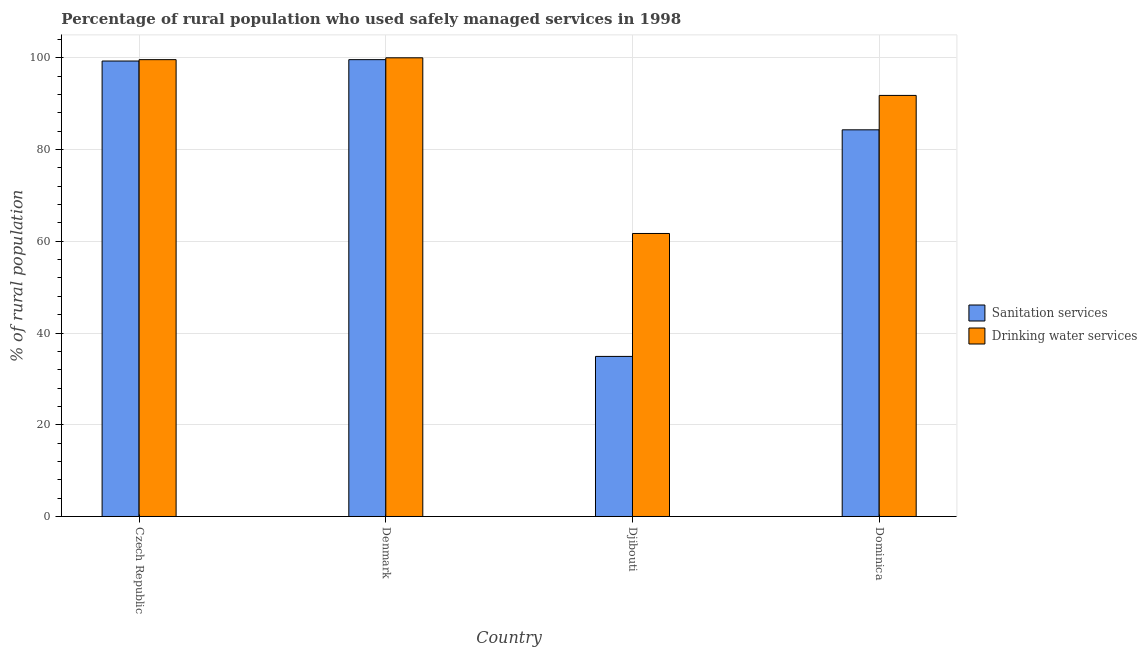How many different coloured bars are there?
Your response must be concise. 2. How many groups of bars are there?
Make the answer very short. 4. Are the number of bars per tick equal to the number of legend labels?
Your answer should be very brief. Yes. Are the number of bars on each tick of the X-axis equal?
Make the answer very short. Yes. How many bars are there on the 2nd tick from the left?
Offer a very short reply. 2. What is the percentage of rural population who used drinking water services in Czech Republic?
Offer a terse response. 99.6. Across all countries, what is the maximum percentage of rural population who used sanitation services?
Provide a succinct answer. 99.6. Across all countries, what is the minimum percentage of rural population who used drinking water services?
Offer a very short reply. 61.7. In which country was the percentage of rural population who used sanitation services maximum?
Ensure brevity in your answer.  Denmark. In which country was the percentage of rural population who used drinking water services minimum?
Offer a very short reply. Djibouti. What is the total percentage of rural population who used drinking water services in the graph?
Provide a succinct answer. 353.1. What is the difference between the percentage of rural population who used sanitation services in Czech Republic and that in Djibouti?
Keep it short and to the point. 64.4. What is the difference between the percentage of rural population who used sanitation services in Djibouti and the percentage of rural population who used drinking water services in Czech Republic?
Ensure brevity in your answer.  -64.7. What is the average percentage of rural population who used sanitation services per country?
Keep it short and to the point. 79.52. What is the difference between the percentage of rural population who used drinking water services and percentage of rural population who used sanitation services in Djibouti?
Keep it short and to the point. 26.8. What is the ratio of the percentage of rural population who used drinking water services in Denmark to that in Djibouti?
Give a very brief answer. 1.62. Is the percentage of rural population who used drinking water services in Djibouti less than that in Dominica?
Offer a terse response. Yes. What is the difference between the highest and the second highest percentage of rural population who used sanitation services?
Ensure brevity in your answer.  0.3. What is the difference between the highest and the lowest percentage of rural population who used sanitation services?
Offer a terse response. 64.7. In how many countries, is the percentage of rural population who used drinking water services greater than the average percentage of rural population who used drinking water services taken over all countries?
Ensure brevity in your answer.  3. What does the 2nd bar from the left in Djibouti represents?
Give a very brief answer. Drinking water services. What does the 1st bar from the right in Denmark represents?
Keep it short and to the point. Drinking water services. How many bars are there?
Ensure brevity in your answer.  8. Are all the bars in the graph horizontal?
Provide a succinct answer. No. What is the difference between two consecutive major ticks on the Y-axis?
Offer a terse response. 20. How are the legend labels stacked?
Provide a short and direct response. Vertical. What is the title of the graph?
Offer a very short reply. Percentage of rural population who used safely managed services in 1998. Does "Forest land" appear as one of the legend labels in the graph?
Provide a succinct answer. No. What is the label or title of the Y-axis?
Provide a short and direct response. % of rural population. What is the % of rural population in Sanitation services in Czech Republic?
Offer a terse response. 99.3. What is the % of rural population of Drinking water services in Czech Republic?
Keep it short and to the point. 99.6. What is the % of rural population in Sanitation services in Denmark?
Offer a terse response. 99.6. What is the % of rural population in Sanitation services in Djibouti?
Offer a terse response. 34.9. What is the % of rural population of Drinking water services in Djibouti?
Make the answer very short. 61.7. What is the % of rural population of Sanitation services in Dominica?
Your answer should be compact. 84.3. What is the % of rural population in Drinking water services in Dominica?
Give a very brief answer. 91.8. Across all countries, what is the maximum % of rural population of Sanitation services?
Your response must be concise. 99.6. Across all countries, what is the minimum % of rural population in Sanitation services?
Offer a terse response. 34.9. Across all countries, what is the minimum % of rural population in Drinking water services?
Give a very brief answer. 61.7. What is the total % of rural population of Sanitation services in the graph?
Keep it short and to the point. 318.1. What is the total % of rural population in Drinking water services in the graph?
Offer a terse response. 353.1. What is the difference between the % of rural population in Sanitation services in Czech Republic and that in Denmark?
Ensure brevity in your answer.  -0.3. What is the difference between the % of rural population in Sanitation services in Czech Republic and that in Djibouti?
Ensure brevity in your answer.  64.4. What is the difference between the % of rural population in Drinking water services in Czech Republic and that in Djibouti?
Ensure brevity in your answer.  37.9. What is the difference between the % of rural population in Drinking water services in Czech Republic and that in Dominica?
Your response must be concise. 7.8. What is the difference between the % of rural population in Sanitation services in Denmark and that in Djibouti?
Offer a very short reply. 64.7. What is the difference between the % of rural population of Drinking water services in Denmark and that in Djibouti?
Offer a terse response. 38.3. What is the difference between the % of rural population of Drinking water services in Denmark and that in Dominica?
Make the answer very short. 8.2. What is the difference between the % of rural population in Sanitation services in Djibouti and that in Dominica?
Your response must be concise. -49.4. What is the difference between the % of rural population in Drinking water services in Djibouti and that in Dominica?
Give a very brief answer. -30.1. What is the difference between the % of rural population in Sanitation services in Czech Republic and the % of rural population in Drinking water services in Djibouti?
Offer a very short reply. 37.6. What is the difference between the % of rural population in Sanitation services in Denmark and the % of rural population in Drinking water services in Djibouti?
Your answer should be compact. 37.9. What is the difference between the % of rural population in Sanitation services in Denmark and the % of rural population in Drinking water services in Dominica?
Offer a terse response. 7.8. What is the difference between the % of rural population in Sanitation services in Djibouti and the % of rural population in Drinking water services in Dominica?
Offer a terse response. -56.9. What is the average % of rural population in Sanitation services per country?
Provide a short and direct response. 79.53. What is the average % of rural population in Drinking water services per country?
Your answer should be very brief. 88.28. What is the difference between the % of rural population of Sanitation services and % of rural population of Drinking water services in Czech Republic?
Provide a short and direct response. -0.3. What is the difference between the % of rural population in Sanitation services and % of rural population in Drinking water services in Djibouti?
Ensure brevity in your answer.  -26.8. What is the difference between the % of rural population in Sanitation services and % of rural population in Drinking water services in Dominica?
Keep it short and to the point. -7.5. What is the ratio of the % of rural population of Sanitation services in Czech Republic to that in Djibouti?
Your response must be concise. 2.85. What is the ratio of the % of rural population in Drinking water services in Czech Republic to that in Djibouti?
Keep it short and to the point. 1.61. What is the ratio of the % of rural population of Sanitation services in Czech Republic to that in Dominica?
Make the answer very short. 1.18. What is the ratio of the % of rural population in Drinking water services in Czech Republic to that in Dominica?
Your response must be concise. 1.08. What is the ratio of the % of rural population in Sanitation services in Denmark to that in Djibouti?
Provide a succinct answer. 2.85. What is the ratio of the % of rural population of Drinking water services in Denmark to that in Djibouti?
Your answer should be very brief. 1.62. What is the ratio of the % of rural population in Sanitation services in Denmark to that in Dominica?
Keep it short and to the point. 1.18. What is the ratio of the % of rural population in Drinking water services in Denmark to that in Dominica?
Give a very brief answer. 1.09. What is the ratio of the % of rural population in Sanitation services in Djibouti to that in Dominica?
Ensure brevity in your answer.  0.41. What is the ratio of the % of rural population of Drinking water services in Djibouti to that in Dominica?
Ensure brevity in your answer.  0.67. What is the difference between the highest and the second highest % of rural population of Sanitation services?
Make the answer very short. 0.3. What is the difference between the highest and the lowest % of rural population in Sanitation services?
Provide a succinct answer. 64.7. What is the difference between the highest and the lowest % of rural population of Drinking water services?
Your answer should be compact. 38.3. 